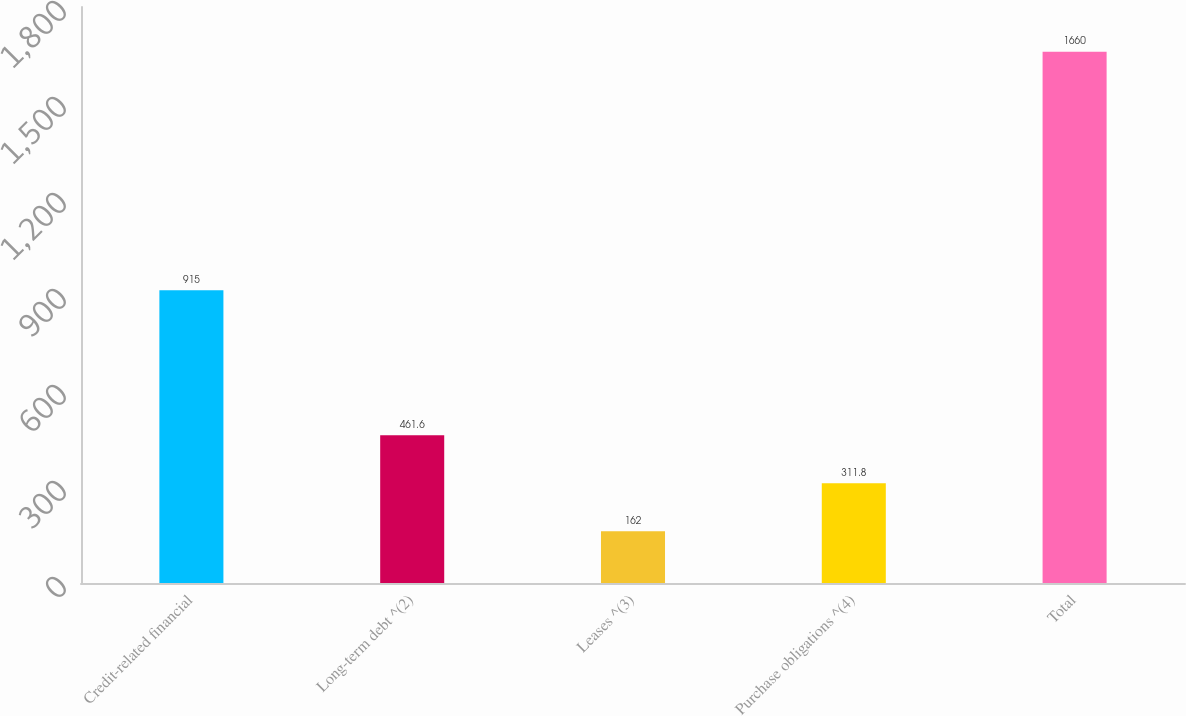<chart> <loc_0><loc_0><loc_500><loc_500><bar_chart><fcel>Credit-related financial<fcel>Long-term debt ^(2)<fcel>Leases ^(3)<fcel>Purchase obligations ^(4)<fcel>Total<nl><fcel>915<fcel>461.6<fcel>162<fcel>311.8<fcel>1660<nl></chart> 